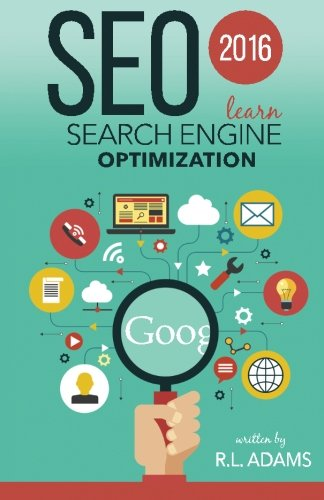Who is the author of this book?
Answer the question using a single word or phrase. R L Adams What is the title of this book? SEO 2016: Learn Search Engine Optimization What is the genre of this book? Computers & Technology Is this a digital technology book? Yes Is this a life story book? No 